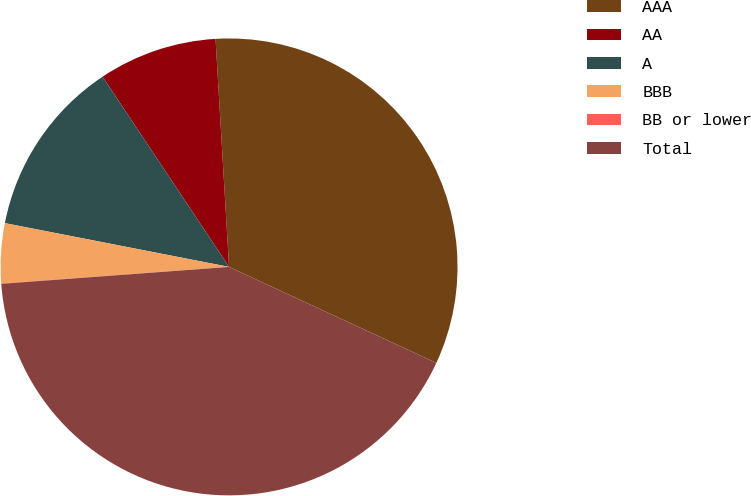Convert chart. <chart><loc_0><loc_0><loc_500><loc_500><pie_chart><fcel>AAA<fcel>AA<fcel>A<fcel>BBB<fcel>BB or lower<fcel>Total<nl><fcel>32.85%<fcel>8.4%<fcel>12.59%<fcel>4.22%<fcel>0.03%<fcel>41.92%<nl></chart> 